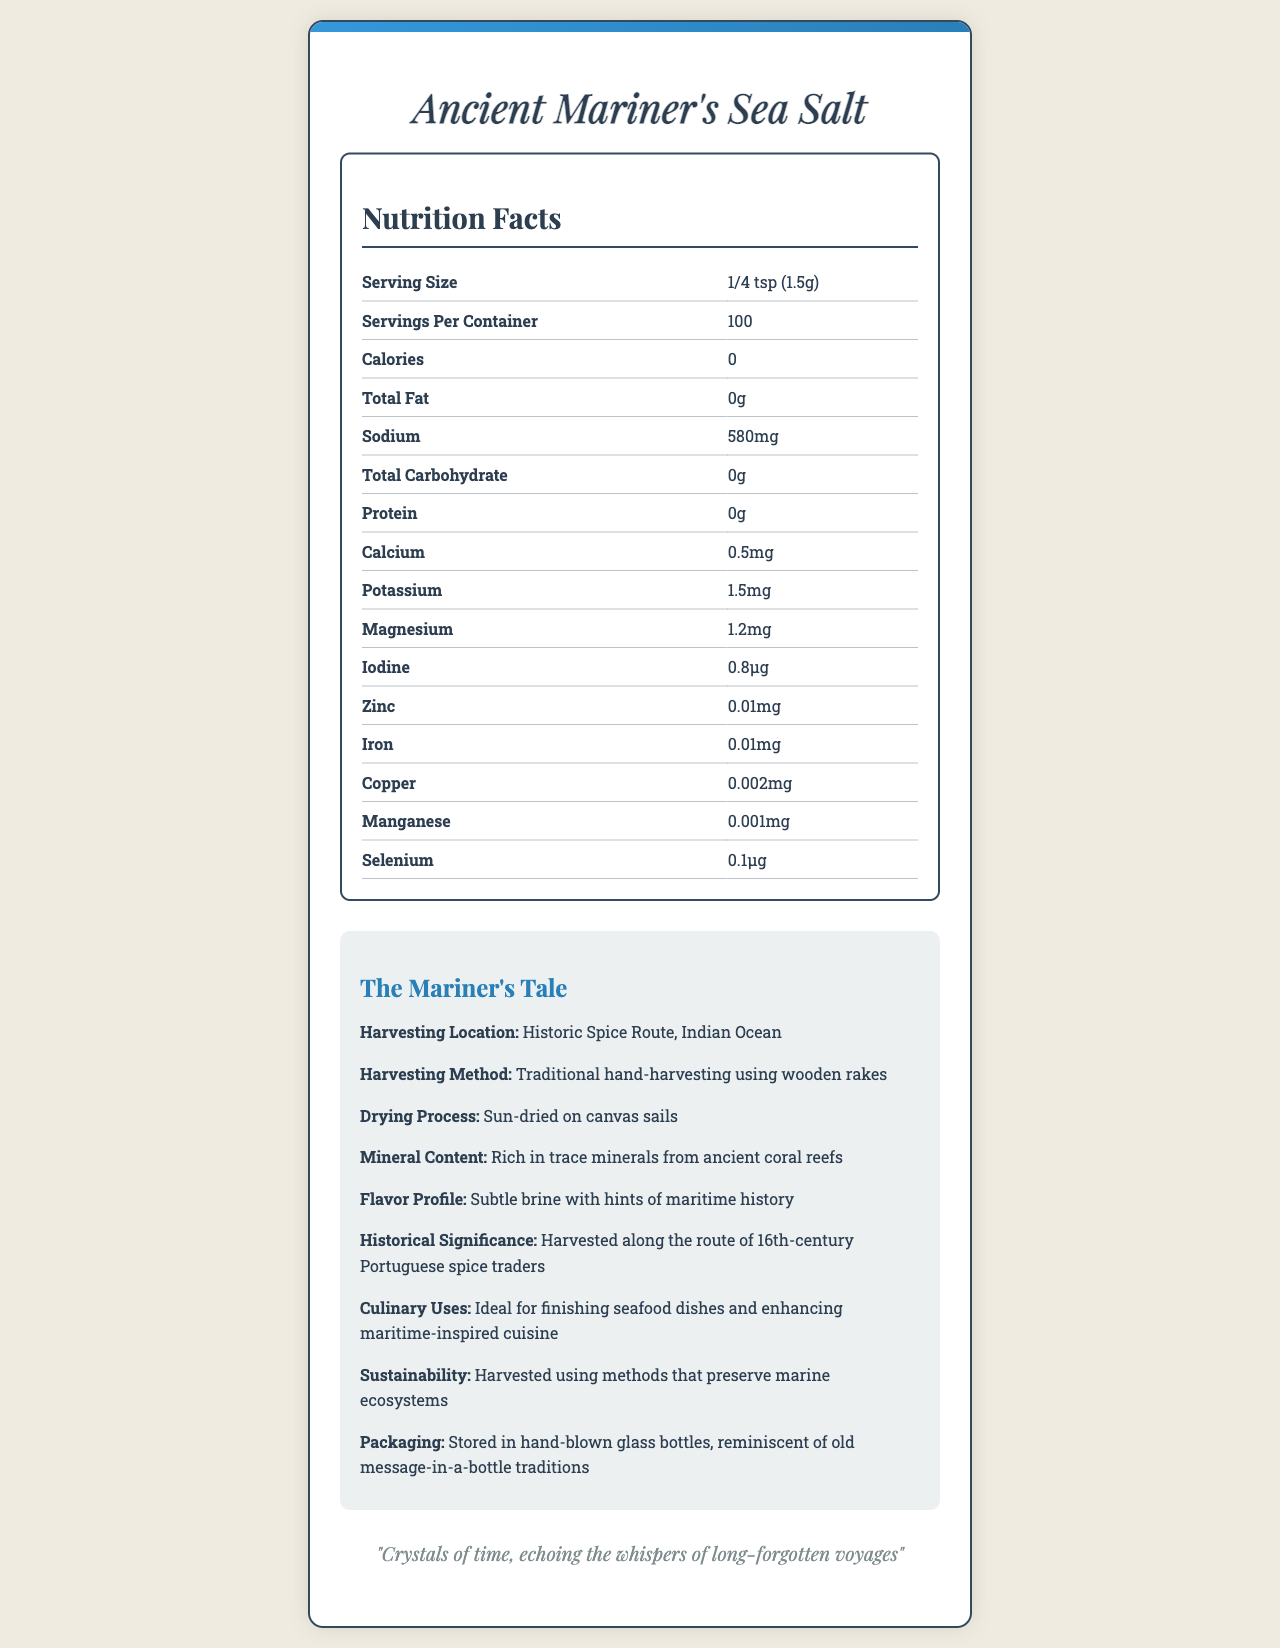what is the serving size of Ancient Mariner's Sea Salt? The serving size is explicitly mentioned in the nutrition facts section of the document.
Answer: 1/4 tsp (1.5g) how many servings are in each container? This information is found in the line "Servings Per Container" in the nutrition facts section.
Answer: 100 how many calories are in one serving of the product? The document lists "Calories: 0" in the nutrition facts section.
Answer: 0 what is the sodium content per serving? The sodium content per serving is specified as 580mg in the nutrition facts section.
Answer: 580mg describe the harvesting method of Ancient Mariner's Sea Salt. This is clearly stated under the "Harvesting Method" in the additional info section of the document.
Answer: Traditional hand-harvesting using wooden rakes which one of these minerals is present in the highest amount per serving? A. Calcium B. Magnesium C. Potassium D. Zinc Potassium content is 1.5mg, while calcium is 0.5mg, magnesium is 1.2mg, and zinc is 0.01mg.
Answer: C. Potassium what is the historical significance of Ancient Mariner's Sea Salt? A. It was used in ancient Egyptian mummification B. It was harvested along the route of 16th-century Portuguese spice traders C. It was first used by ancient Romans D. It was discovered by 18th-century British sailors The historical significance is specified as being harvested along the route of 16th-century Portuguese spice traders.
Answer: B. It was harvested along the route of 16th-century Portuguese spice traders is the product sustainable? The document states that the product is harvested using methods that preserve marine ecosystems, indicating sustainability.
Answer: Yes summarize the main idea of the document. The document includes nutritional data, highlights the traditional and ecological harvesting methods, emphasizes the rich mineral content, ties the product to maritime history, and notes its culinary uses and packaging.
Answer: The document provides comprehensive information about "Ancient Mariner's Sea Salt," detailing nutritional facts, harvesting methods, mineral content, historical significance, and sustainable practices. what is the exact flavor profile described in the document? This specific phrase is used under the "Flavor Profile" in the additional info section.
Answer: Subtle brine with hints of maritime history where is the harvesting location of the salt? The harvesting location is specified under the "Harvesting Location" in the additional info section.
Answer: Historic Spice Route, Indian Ocean who were the Portuguese spice traders mentioned in the historical significance? The document states that the salt was harvested along the route of 16th-century Portuguese spice traders but does not detail specific traders.
Answer: Not enough information 